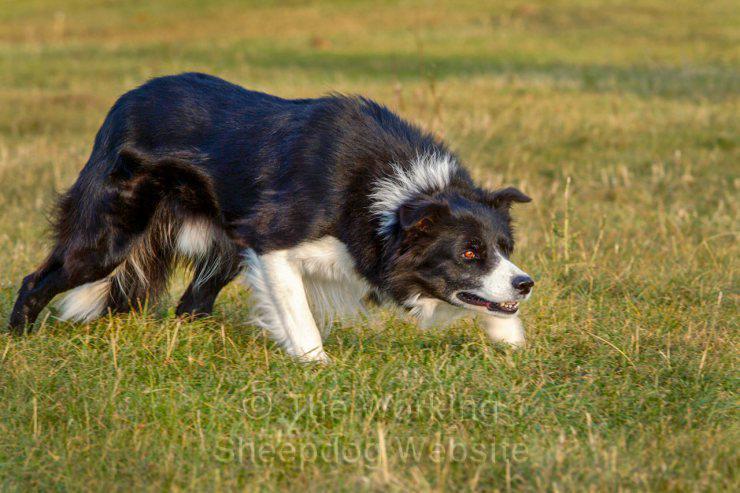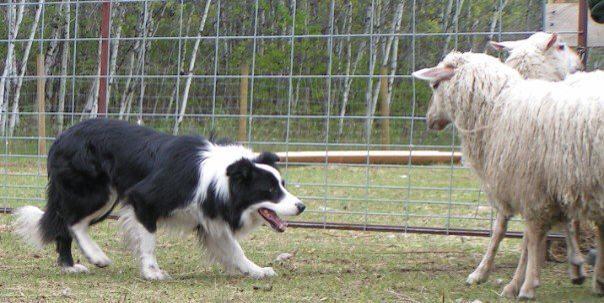The first image is the image on the left, the second image is the image on the right. Examine the images to the left and right. Is the description "One image shows a dog to the right of sheep, and the other shows a dog to the left of sheep." accurate? Answer yes or no. No. 